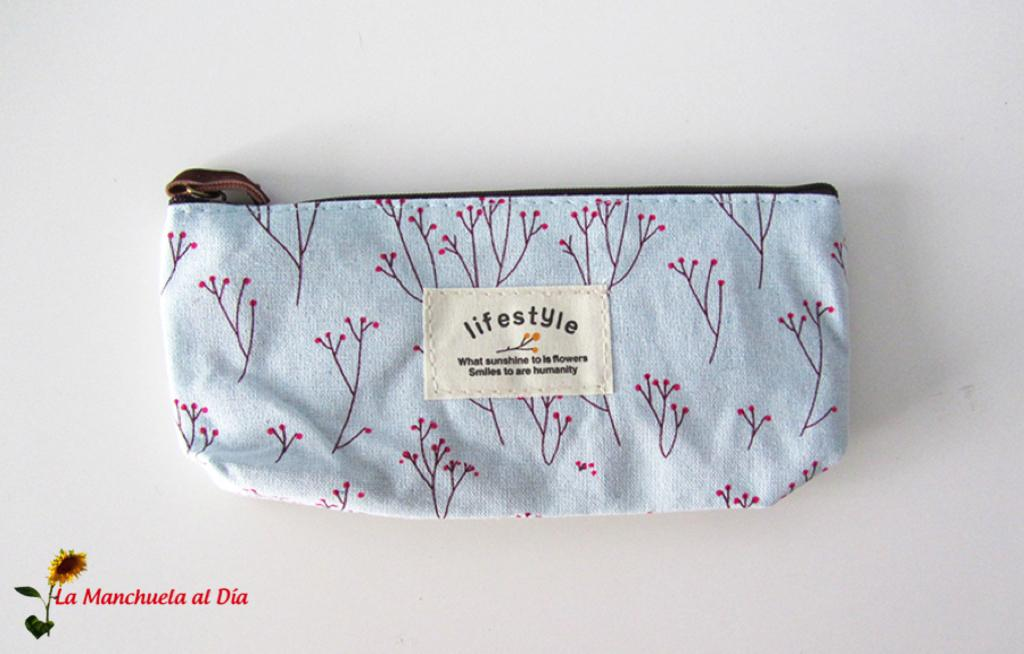What object is present in the image that can be used for carrying items? There is a bag in the image that can be used for carrying items. What additional feature can be seen on the bag? The bag has a label on it. On what surface is the bag placed in the image? The bag is placed on a white surface. Can you describe any additional elements in the image that are not part of the bag? There is a watermark in the bottom left side of the image. How does the bag provide comfort to the person in the image? The image does not depict a person, and the bag's comfort level cannot be determined from the image. 